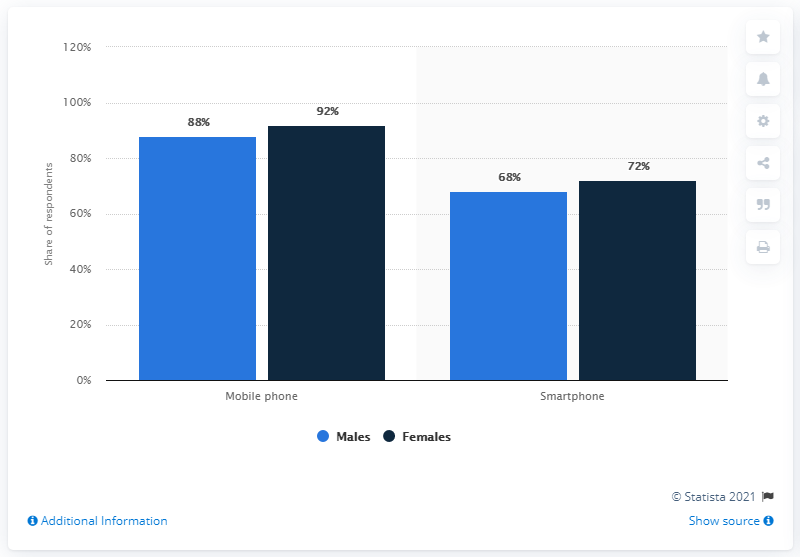List a handful of essential elements in this visual. The difference between the highest and lowest shares for males is 20%. The blue chart contains the highest percentage of 88. 